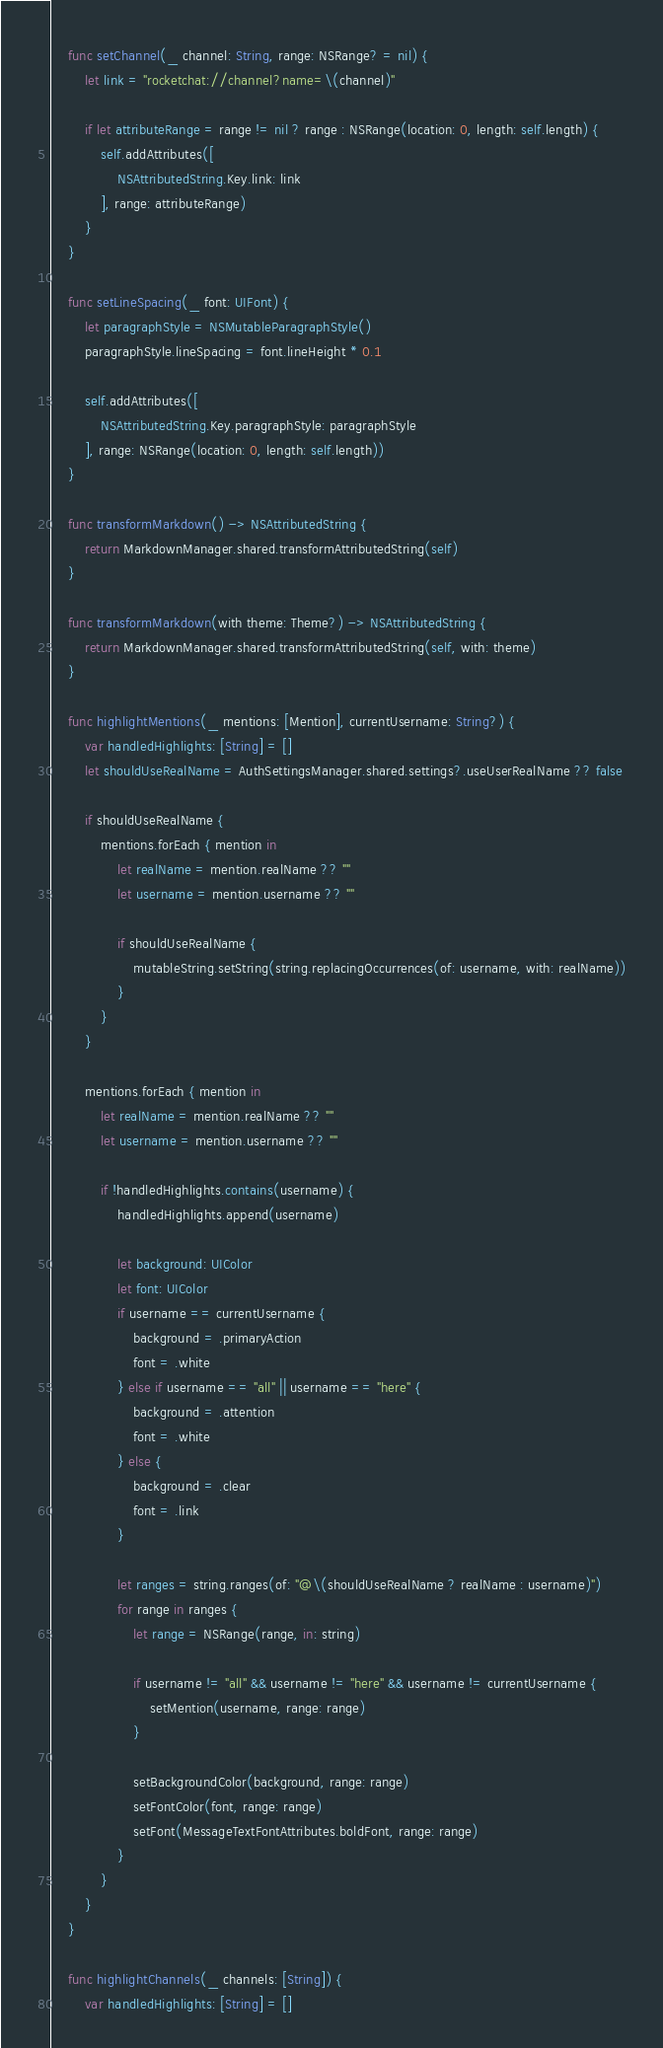<code> <loc_0><loc_0><loc_500><loc_500><_Swift_>
    func setChannel(_ channel: String, range: NSRange? = nil) {
        let link = "rocketchat://channel?name=\(channel)"

        if let attributeRange = range != nil ? range : NSRange(location: 0, length: self.length) {
            self.addAttributes([
                NSAttributedString.Key.link: link
            ], range: attributeRange)
        }
    }

    func setLineSpacing(_ font: UIFont) {
        let paragraphStyle = NSMutableParagraphStyle()
        paragraphStyle.lineSpacing = font.lineHeight * 0.1

        self.addAttributes([
            NSAttributedString.Key.paragraphStyle: paragraphStyle
        ], range: NSRange(location: 0, length: self.length))
    }

    func transformMarkdown() -> NSAttributedString {
        return MarkdownManager.shared.transformAttributedString(self)
    }

    func transformMarkdown(with theme: Theme?) -> NSAttributedString {
        return MarkdownManager.shared.transformAttributedString(self, with: theme)
    }

    func highlightMentions(_ mentions: [Mention], currentUsername: String?) {
        var handledHighlights: [String] = []
        let shouldUseRealName = AuthSettingsManager.shared.settings?.useUserRealName ?? false

        if shouldUseRealName {
            mentions.forEach { mention in
                let realName = mention.realName ?? ""
                let username = mention.username ?? ""

                if shouldUseRealName {
                    mutableString.setString(string.replacingOccurrences(of: username, with: realName))
                }
            }
        }

        mentions.forEach { mention in
            let realName = mention.realName ?? ""
            let username = mention.username ?? ""

            if !handledHighlights.contains(username) {
                handledHighlights.append(username)

                let background: UIColor
                let font: UIColor
                if username == currentUsername {
                    background = .primaryAction
                    font = .white
                } else if username == "all" || username == "here" {
                    background = .attention
                    font = .white
                } else {
                    background = .clear
                    font = .link
                }

                let ranges = string.ranges(of: "@\(shouldUseRealName ? realName : username)")
                for range in ranges {
                    let range = NSRange(range, in: string)

                    if username != "all" && username != "here" && username != currentUsername {
                        setMention(username, range: range)
                    }

                    setBackgroundColor(background, range: range)
                    setFontColor(font, range: range)
                    setFont(MessageTextFontAttributes.boldFont, range: range)
                }
            }
        }
    }

    func highlightChannels(_ channels: [String]) {
        var handledHighlights: [String] = []
</code> 